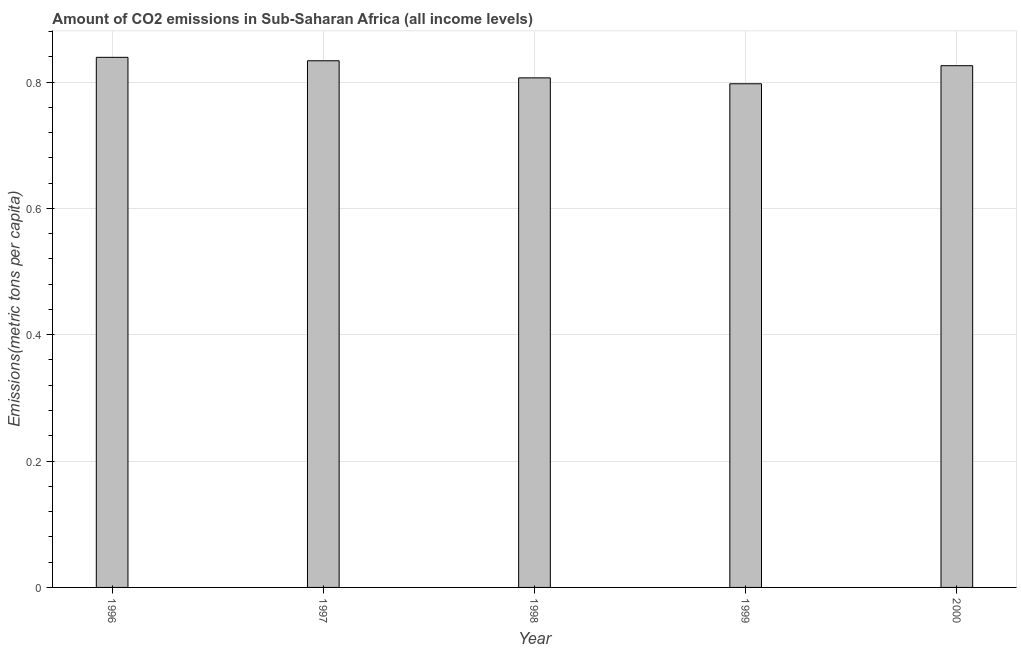Does the graph contain grids?
Keep it short and to the point. Yes. What is the title of the graph?
Make the answer very short. Amount of CO2 emissions in Sub-Saharan Africa (all income levels). What is the label or title of the X-axis?
Offer a very short reply. Year. What is the label or title of the Y-axis?
Provide a short and direct response. Emissions(metric tons per capita). What is the amount of co2 emissions in 1998?
Ensure brevity in your answer.  0.81. Across all years, what is the maximum amount of co2 emissions?
Your answer should be compact. 0.84. Across all years, what is the minimum amount of co2 emissions?
Offer a very short reply. 0.8. In which year was the amount of co2 emissions minimum?
Ensure brevity in your answer.  1999. What is the sum of the amount of co2 emissions?
Offer a terse response. 4.1. What is the difference between the amount of co2 emissions in 1998 and 1999?
Give a very brief answer. 0.01. What is the average amount of co2 emissions per year?
Your response must be concise. 0.82. What is the median amount of co2 emissions?
Provide a succinct answer. 0.83. In how many years, is the amount of co2 emissions greater than 0.68 metric tons per capita?
Ensure brevity in your answer.  5. Do a majority of the years between 2000 and 1996 (inclusive) have amount of co2 emissions greater than 0.6 metric tons per capita?
Provide a succinct answer. Yes. What is the ratio of the amount of co2 emissions in 1998 to that in 2000?
Your answer should be very brief. 0.98. Is the amount of co2 emissions in 1997 less than that in 1999?
Your answer should be very brief. No. What is the difference between the highest and the second highest amount of co2 emissions?
Keep it short and to the point. 0.01. Are all the bars in the graph horizontal?
Provide a short and direct response. No. What is the Emissions(metric tons per capita) of 1996?
Offer a terse response. 0.84. What is the Emissions(metric tons per capita) of 1997?
Your answer should be compact. 0.83. What is the Emissions(metric tons per capita) in 1998?
Your answer should be compact. 0.81. What is the Emissions(metric tons per capita) of 1999?
Your answer should be compact. 0.8. What is the Emissions(metric tons per capita) of 2000?
Offer a terse response. 0.83. What is the difference between the Emissions(metric tons per capita) in 1996 and 1997?
Offer a terse response. 0.01. What is the difference between the Emissions(metric tons per capita) in 1996 and 1998?
Your response must be concise. 0.03. What is the difference between the Emissions(metric tons per capita) in 1996 and 1999?
Offer a terse response. 0.04. What is the difference between the Emissions(metric tons per capita) in 1996 and 2000?
Provide a short and direct response. 0.01. What is the difference between the Emissions(metric tons per capita) in 1997 and 1998?
Ensure brevity in your answer.  0.03. What is the difference between the Emissions(metric tons per capita) in 1997 and 1999?
Offer a very short reply. 0.04. What is the difference between the Emissions(metric tons per capita) in 1997 and 2000?
Offer a very short reply. 0.01. What is the difference between the Emissions(metric tons per capita) in 1998 and 1999?
Offer a very short reply. 0.01. What is the difference between the Emissions(metric tons per capita) in 1998 and 2000?
Keep it short and to the point. -0.02. What is the difference between the Emissions(metric tons per capita) in 1999 and 2000?
Your response must be concise. -0.03. What is the ratio of the Emissions(metric tons per capita) in 1996 to that in 1997?
Provide a succinct answer. 1.01. What is the ratio of the Emissions(metric tons per capita) in 1996 to that in 1999?
Ensure brevity in your answer.  1.05. What is the ratio of the Emissions(metric tons per capita) in 1997 to that in 1998?
Your response must be concise. 1.03. What is the ratio of the Emissions(metric tons per capita) in 1997 to that in 1999?
Keep it short and to the point. 1.05. What is the ratio of the Emissions(metric tons per capita) in 1998 to that in 1999?
Provide a short and direct response. 1.01. 